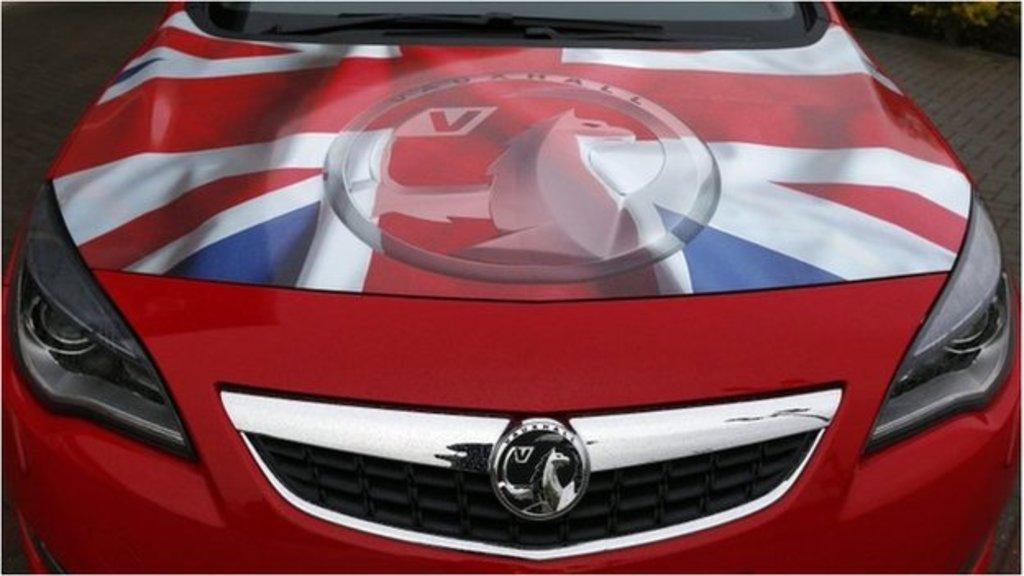What type of vehicle is in the image? There is a red car in the image. What can be observed about the appearance of the car? The car has a colorful painting on it. How many trees are visible in the image? There are no trees visible in the image, as it only features a red car with a colorful painting on it. 